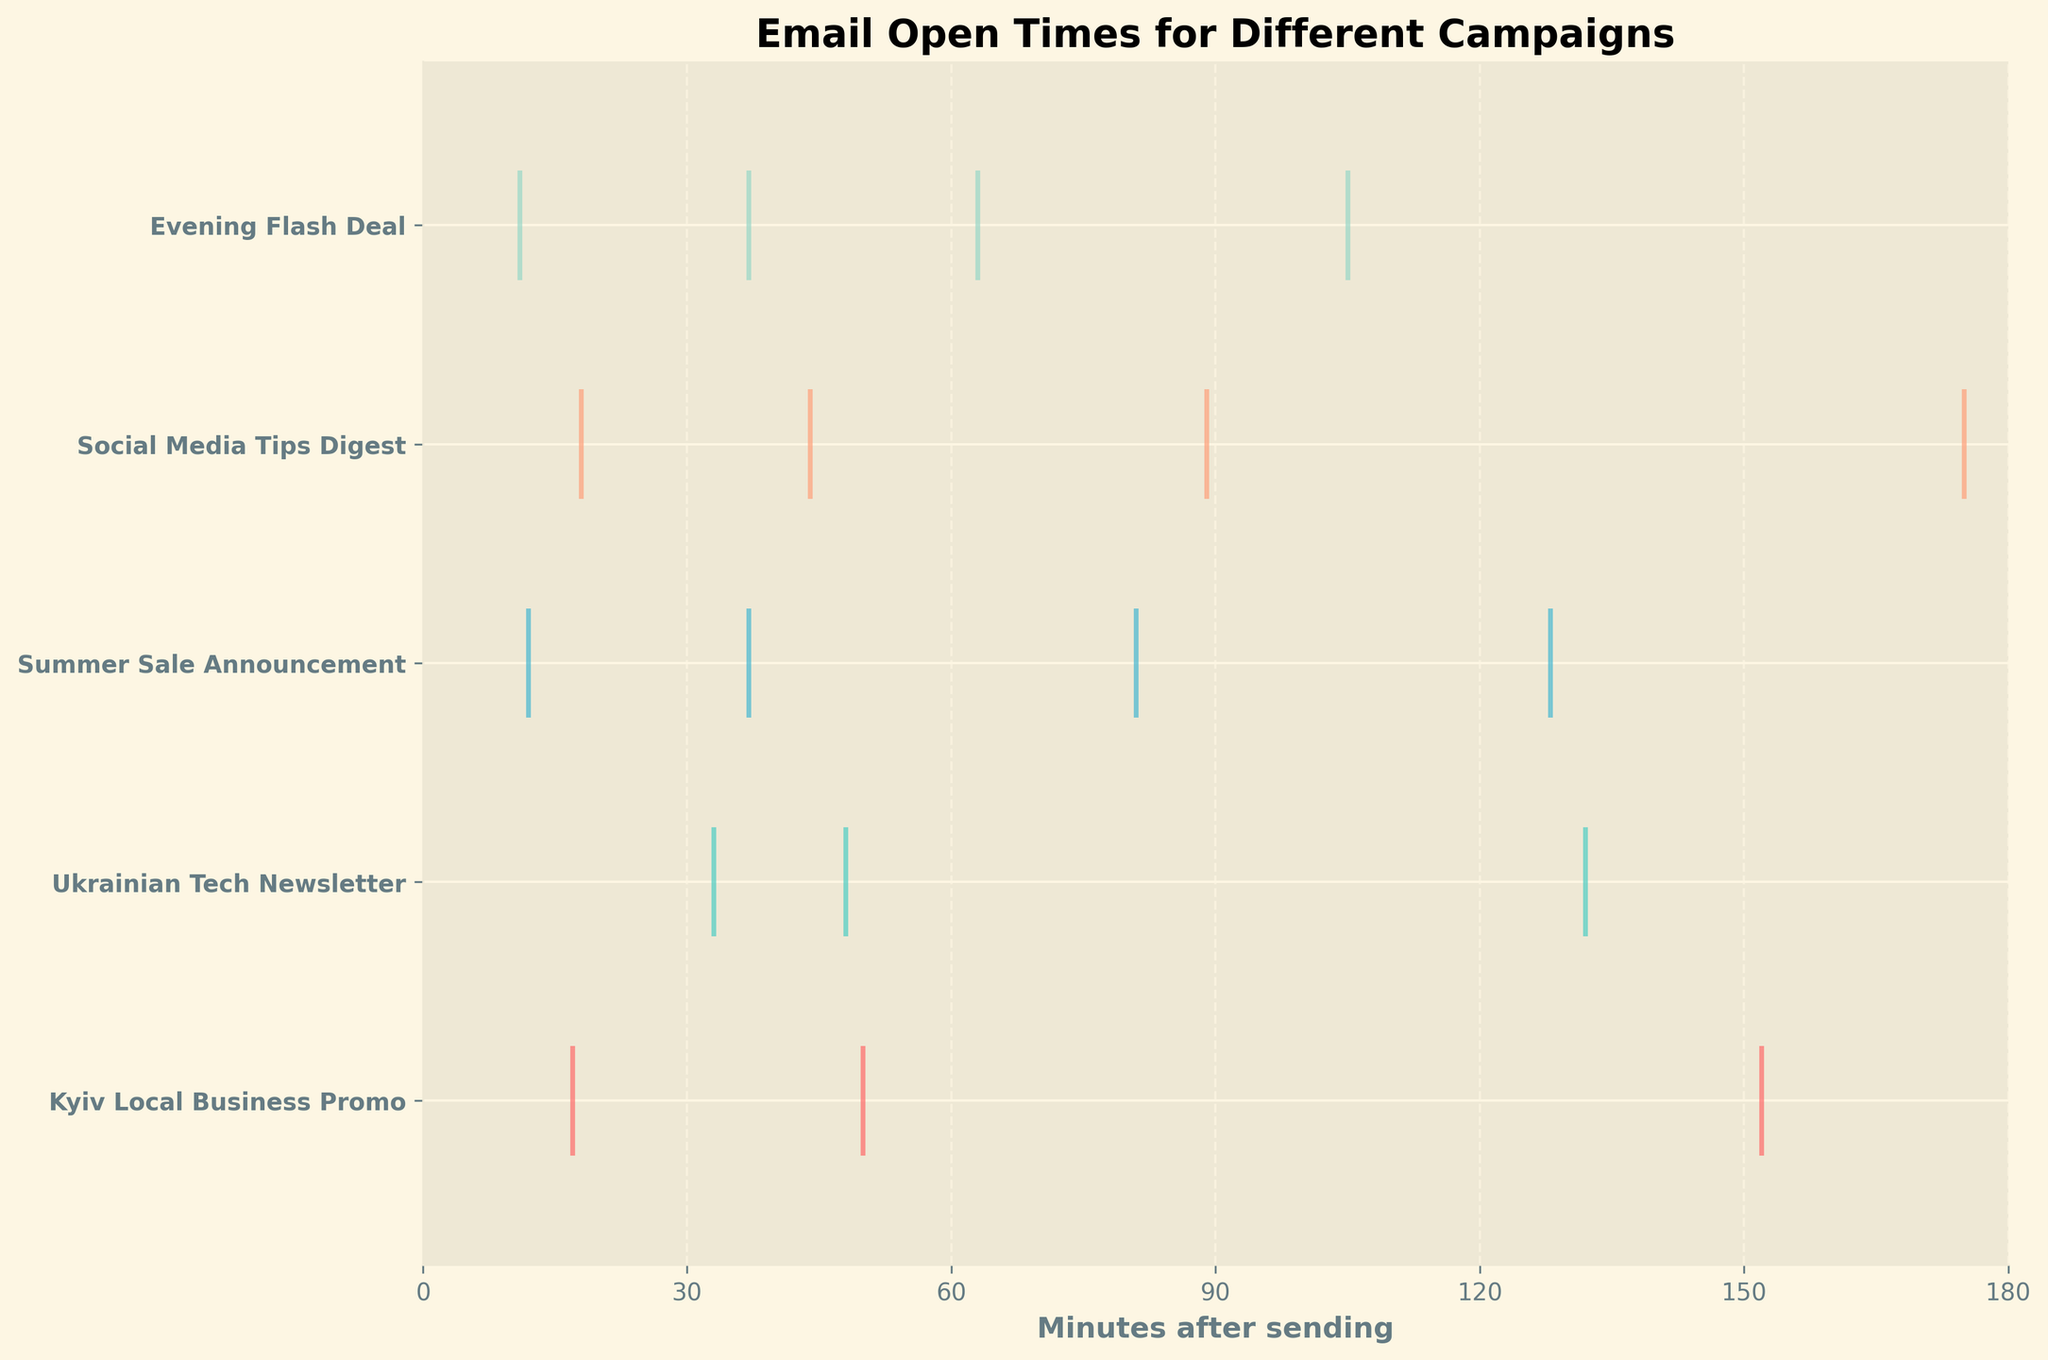What is the title of the plot? The title is typically found at the top center of the plot; in this case, it reads "Email Open Times for Different Campaigns".
Answer: Email Open Times for Different Campaigns How many campaigns are being compared in the plot? Count the unique rows in the y-axis label. There are five unique campaign names listed.
Answer: 5 What does the x-axis represent? Look at the x-axis label. It indicates "Minutes after sending", marking the time from when the email was sent until it was opened.
Answer: Minutes after sending Which campaign had the latest email open time recorded? Identify the longest bar in the plot and check which campaign it aligns with on the y-axis. "Evening Flash Deal" has the latest open time recorded.
Answer: Evening Flash Deal Which campaign had the shortest email open time? Identify the shortest bar in the plot and check which campaign it aligns with. The "Evening Flash Deal" campaign has the shortest open time.
Answer: Evening Flash Deal On average, which campaign had emails opened the soonest after sending? Calculate the average delta minutes for each campaign. The "Kyiv Local Business Promo" seems to have emails opened soonest as its cluster is more on the left side of the timeline.
Answer: Kyiv Local Business Promo Did any campaign have an email opened more than 90 minutes after sending? Check the timeline if any bars extend past the 90-minute mark. "Ukrainian Tech Newsletter", "Summer Sale Announcement", and "Social Media Tips Digest" all have instances.
Answer: Yes Compare "Summer Sale Announcement" and "Social Media Tips Digest". Which had a more scattered open time distribution? Visually check for bars that span a wider range on the x-axis. "Summer Sale Announcement" has a wider distribution of open times than "Social Media Tips Digest".
Answer: Summer Sale Announcement For the "Kyiv Local Business Promo", what is the time difference between the earliest and latest email opened? Subtract the earliest recorded open time (17 minutes) from the latest (152 minutes).
Answer: 130 minutes Which campaign has the most clustered open times, indicating a shorter span between min and max open times? By visually assessing compactness, the "Evening Flash Deal" has the most clustered open times.
Answer: Evening Flash Deal 